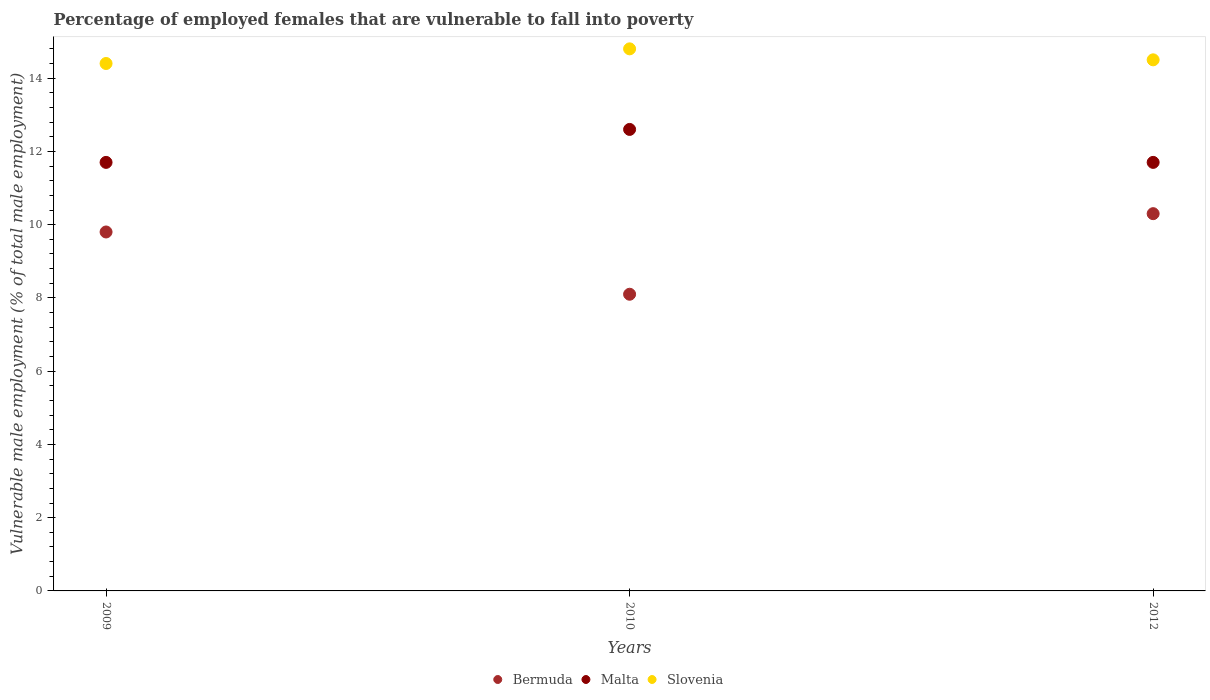How many different coloured dotlines are there?
Offer a terse response. 3. Is the number of dotlines equal to the number of legend labels?
Ensure brevity in your answer.  Yes. What is the percentage of employed females who are vulnerable to fall into poverty in Malta in 2009?
Ensure brevity in your answer.  11.7. Across all years, what is the maximum percentage of employed females who are vulnerable to fall into poverty in Slovenia?
Provide a short and direct response. 14.8. Across all years, what is the minimum percentage of employed females who are vulnerable to fall into poverty in Bermuda?
Provide a succinct answer. 8.1. What is the total percentage of employed females who are vulnerable to fall into poverty in Bermuda in the graph?
Give a very brief answer. 28.2. What is the difference between the percentage of employed females who are vulnerable to fall into poverty in Slovenia in 2009 and that in 2012?
Make the answer very short. -0.1. What is the difference between the percentage of employed females who are vulnerable to fall into poverty in Malta in 2012 and the percentage of employed females who are vulnerable to fall into poverty in Bermuda in 2010?
Your answer should be very brief. 3.6. What is the average percentage of employed females who are vulnerable to fall into poverty in Malta per year?
Your answer should be very brief. 12. In the year 2010, what is the difference between the percentage of employed females who are vulnerable to fall into poverty in Slovenia and percentage of employed females who are vulnerable to fall into poverty in Malta?
Provide a succinct answer. 2.2. In how many years, is the percentage of employed females who are vulnerable to fall into poverty in Malta greater than 2 %?
Provide a succinct answer. 3. What is the ratio of the percentage of employed females who are vulnerable to fall into poverty in Slovenia in 2010 to that in 2012?
Keep it short and to the point. 1.02. Is the percentage of employed females who are vulnerable to fall into poverty in Malta in 2009 less than that in 2012?
Your answer should be very brief. No. Is the difference between the percentage of employed females who are vulnerable to fall into poverty in Slovenia in 2010 and 2012 greater than the difference between the percentage of employed females who are vulnerable to fall into poverty in Malta in 2010 and 2012?
Make the answer very short. No. What is the difference between the highest and the second highest percentage of employed females who are vulnerable to fall into poverty in Bermuda?
Offer a very short reply. 0.5. What is the difference between the highest and the lowest percentage of employed females who are vulnerable to fall into poverty in Slovenia?
Your answer should be compact. 0.4. In how many years, is the percentage of employed females who are vulnerable to fall into poverty in Slovenia greater than the average percentage of employed females who are vulnerable to fall into poverty in Slovenia taken over all years?
Make the answer very short. 1. Is the sum of the percentage of employed females who are vulnerable to fall into poverty in Bermuda in 2009 and 2010 greater than the maximum percentage of employed females who are vulnerable to fall into poverty in Malta across all years?
Your answer should be compact. Yes. Is the percentage of employed females who are vulnerable to fall into poverty in Malta strictly greater than the percentage of employed females who are vulnerable to fall into poverty in Slovenia over the years?
Your answer should be compact. No. Is the percentage of employed females who are vulnerable to fall into poverty in Slovenia strictly less than the percentage of employed females who are vulnerable to fall into poverty in Malta over the years?
Offer a terse response. No. How many dotlines are there?
Provide a short and direct response. 3. How many years are there in the graph?
Give a very brief answer. 3. What is the difference between two consecutive major ticks on the Y-axis?
Offer a terse response. 2. Does the graph contain any zero values?
Make the answer very short. No. Where does the legend appear in the graph?
Provide a short and direct response. Bottom center. How many legend labels are there?
Your response must be concise. 3. What is the title of the graph?
Ensure brevity in your answer.  Percentage of employed females that are vulnerable to fall into poverty. What is the label or title of the Y-axis?
Make the answer very short. Vulnerable male employment (% of total male employment). What is the Vulnerable male employment (% of total male employment) of Bermuda in 2009?
Your response must be concise. 9.8. What is the Vulnerable male employment (% of total male employment) in Malta in 2009?
Provide a succinct answer. 11.7. What is the Vulnerable male employment (% of total male employment) of Slovenia in 2009?
Your answer should be compact. 14.4. What is the Vulnerable male employment (% of total male employment) in Bermuda in 2010?
Offer a very short reply. 8.1. What is the Vulnerable male employment (% of total male employment) in Malta in 2010?
Offer a terse response. 12.6. What is the Vulnerable male employment (% of total male employment) of Slovenia in 2010?
Provide a succinct answer. 14.8. What is the Vulnerable male employment (% of total male employment) in Bermuda in 2012?
Your response must be concise. 10.3. What is the Vulnerable male employment (% of total male employment) of Malta in 2012?
Your answer should be compact. 11.7. What is the Vulnerable male employment (% of total male employment) of Slovenia in 2012?
Your answer should be compact. 14.5. Across all years, what is the maximum Vulnerable male employment (% of total male employment) of Bermuda?
Offer a terse response. 10.3. Across all years, what is the maximum Vulnerable male employment (% of total male employment) in Malta?
Keep it short and to the point. 12.6. Across all years, what is the maximum Vulnerable male employment (% of total male employment) in Slovenia?
Provide a short and direct response. 14.8. Across all years, what is the minimum Vulnerable male employment (% of total male employment) in Bermuda?
Provide a short and direct response. 8.1. Across all years, what is the minimum Vulnerable male employment (% of total male employment) of Malta?
Ensure brevity in your answer.  11.7. Across all years, what is the minimum Vulnerable male employment (% of total male employment) in Slovenia?
Offer a very short reply. 14.4. What is the total Vulnerable male employment (% of total male employment) in Bermuda in the graph?
Your answer should be very brief. 28.2. What is the total Vulnerable male employment (% of total male employment) of Malta in the graph?
Make the answer very short. 36. What is the total Vulnerable male employment (% of total male employment) in Slovenia in the graph?
Your answer should be compact. 43.7. What is the difference between the Vulnerable male employment (% of total male employment) of Slovenia in 2009 and that in 2010?
Keep it short and to the point. -0.4. What is the difference between the Vulnerable male employment (% of total male employment) of Bermuda in 2010 and that in 2012?
Your response must be concise. -2.2. What is the difference between the Vulnerable male employment (% of total male employment) of Malta in 2010 and that in 2012?
Offer a terse response. 0.9. What is the difference between the Vulnerable male employment (% of total male employment) of Slovenia in 2010 and that in 2012?
Provide a short and direct response. 0.3. What is the difference between the Vulnerable male employment (% of total male employment) in Bermuda in 2009 and the Vulnerable male employment (% of total male employment) in Malta in 2010?
Keep it short and to the point. -2.8. What is the difference between the Vulnerable male employment (% of total male employment) in Malta in 2009 and the Vulnerable male employment (% of total male employment) in Slovenia in 2010?
Give a very brief answer. -3.1. What is the difference between the Vulnerable male employment (% of total male employment) of Bermuda in 2009 and the Vulnerable male employment (% of total male employment) of Malta in 2012?
Your response must be concise. -1.9. What is the difference between the Vulnerable male employment (% of total male employment) of Bermuda in 2009 and the Vulnerable male employment (% of total male employment) of Slovenia in 2012?
Give a very brief answer. -4.7. What is the difference between the Vulnerable male employment (% of total male employment) in Malta in 2009 and the Vulnerable male employment (% of total male employment) in Slovenia in 2012?
Offer a very short reply. -2.8. What is the difference between the Vulnerable male employment (% of total male employment) in Bermuda in 2010 and the Vulnerable male employment (% of total male employment) in Malta in 2012?
Offer a terse response. -3.6. What is the difference between the Vulnerable male employment (% of total male employment) in Malta in 2010 and the Vulnerable male employment (% of total male employment) in Slovenia in 2012?
Keep it short and to the point. -1.9. What is the average Vulnerable male employment (% of total male employment) of Bermuda per year?
Provide a succinct answer. 9.4. What is the average Vulnerable male employment (% of total male employment) of Malta per year?
Give a very brief answer. 12. What is the average Vulnerable male employment (% of total male employment) of Slovenia per year?
Give a very brief answer. 14.57. In the year 2009, what is the difference between the Vulnerable male employment (% of total male employment) of Bermuda and Vulnerable male employment (% of total male employment) of Malta?
Offer a very short reply. -1.9. In the year 2009, what is the difference between the Vulnerable male employment (% of total male employment) in Bermuda and Vulnerable male employment (% of total male employment) in Slovenia?
Your answer should be compact. -4.6. In the year 2009, what is the difference between the Vulnerable male employment (% of total male employment) in Malta and Vulnerable male employment (% of total male employment) in Slovenia?
Offer a very short reply. -2.7. In the year 2010, what is the difference between the Vulnerable male employment (% of total male employment) in Bermuda and Vulnerable male employment (% of total male employment) in Slovenia?
Your answer should be very brief. -6.7. In the year 2012, what is the difference between the Vulnerable male employment (% of total male employment) in Bermuda and Vulnerable male employment (% of total male employment) in Slovenia?
Your answer should be very brief. -4.2. In the year 2012, what is the difference between the Vulnerable male employment (% of total male employment) in Malta and Vulnerable male employment (% of total male employment) in Slovenia?
Keep it short and to the point. -2.8. What is the ratio of the Vulnerable male employment (% of total male employment) of Bermuda in 2009 to that in 2010?
Give a very brief answer. 1.21. What is the ratio of the Vulnerable male employment (% of total male employment) in Bermuda in 2009 to that in 2012?
Offer a very short reply. 0.95. What is the ratio of the Vulnerable male employment (% of total male employment) in Bermuda in 2010 to that in 2012?
Your answer should be very brief. 0.79. What is the ratio of the Vulnerable male employment (% of total male employment) of Slovenia in 2010 to that in 2012?
Offer a terse response. 1.02. What is the difference between the highest and the second highest Vulnerable male employment (% of total male employment) of Bermuda?
Provide a short and direct response. 0.5. What is the difference between the highest and the second highest Vulnerable male employment (% of total male employment) in Malta?
Provide a short and direct response. 0.9. 